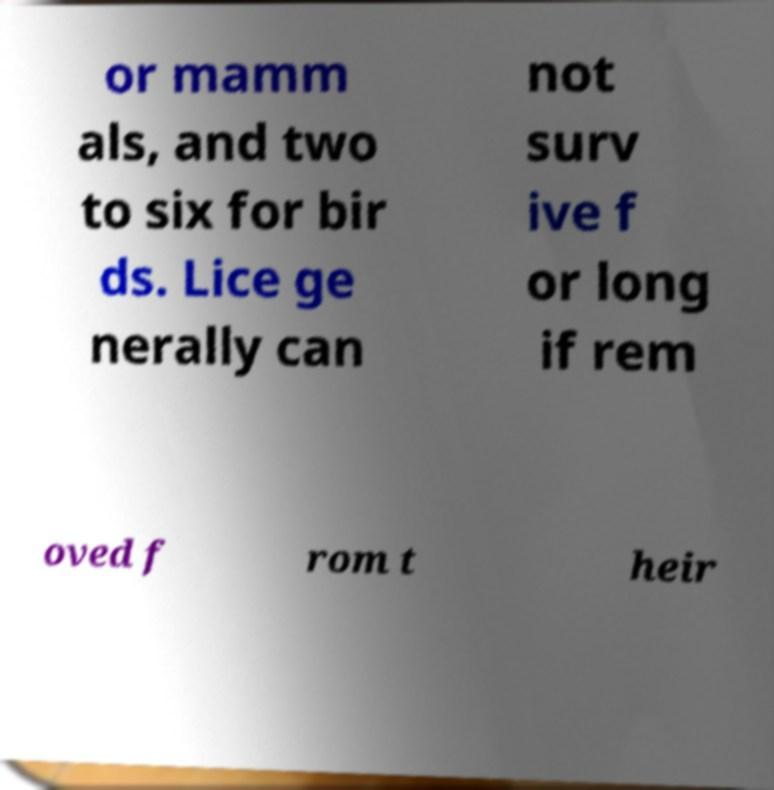What messages or text are displayed in this image? I need them in a readable, typed format. or mamm als, and two to six for bir ds. Lice ge nerally can not surv ive f or long if rem oved f rom t heir 